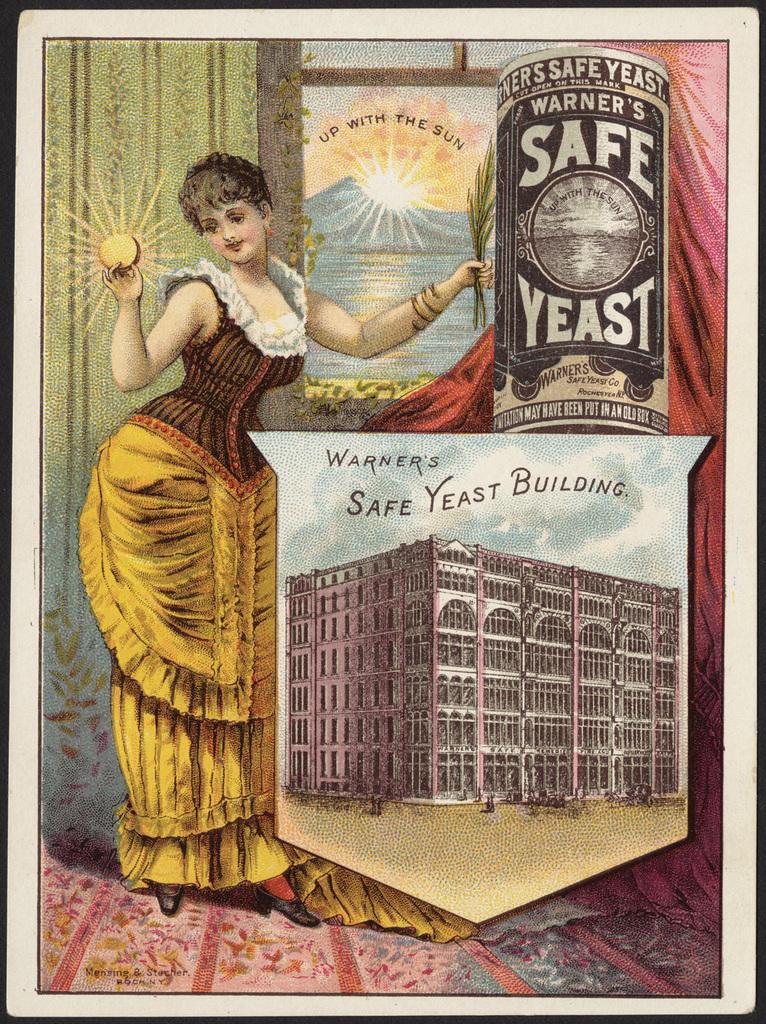Who owns this building?
Provide a short and direct response. Warner's. 